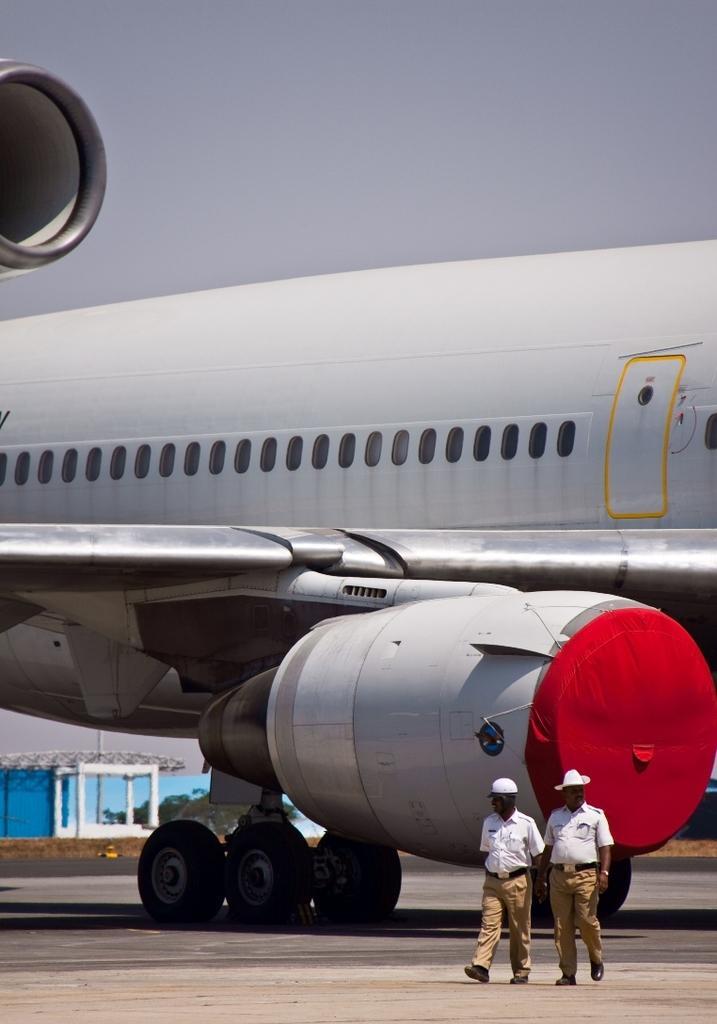Describe this image in one or two sentences. In this picture we can see two people and an airplane on the ground and in the background we can see trees, sky and some objects. 